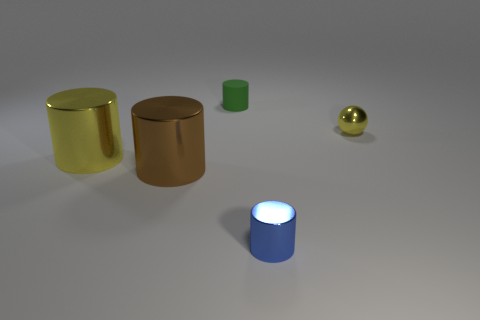There is a ball that is made of the same material as the brown cylinder; what is its color?
Your answer should be compact. Yellow. How many matte objects are tiny blue things or big cylinders?
Offer a very short reply. 0. Is the material of the large brown cylinder the same as the yellow ball?
Keep it short and to the point. Yes. There is a yellow metal object that is to the left of the small green rubber object; what shape is it?
Provide a short and direct response. Cylinder. Is there a tiny yellow metallic thing that is in front of the small metal object on the right side of the small blue metal object?
Your answer should be very brief. No. Are there any matte cubes of the same size as the brown shiny cylinder?
Your answer should be very brief. No. There is a tiny thing behind the yellow ball; does it have the same color as the small sphere?
Offer a very short reply. No. What size is the brown thing?
Give a very brief answer. Large. There is a cylinder that is behind the small sphere that is right of the large brown shiny cylinder; what is its size?
Provide a succinct answer. Small. How many large cylinders are the same color as the small shiny sphere?
Your answer should be compact. 1. 